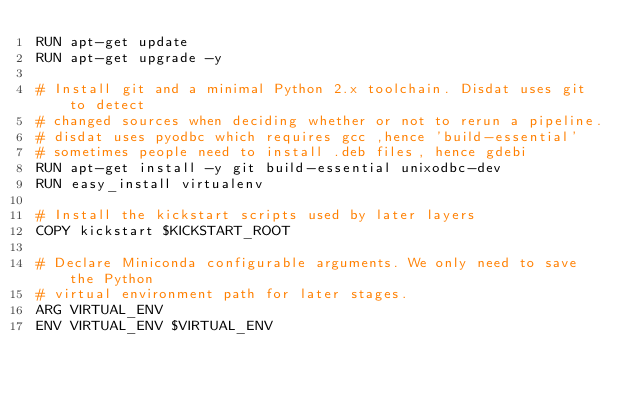<code> <loc_0><loc_0><loc_500><loc_500><_Dockerfile_>RUN apt-get update
RUN apt-get upgrade -y

# Install git and a minimal Python 2.x toolchain. Disdat uses git to detect
# changed sources when deciding whether or not to rerun a pipeline.
# disdat uses pyodbc which requires gcc ,hence 'build-essential'
# sometimes people need to install .deb files, hence gdebi
RUN apt-get install -y git build-essential unixodbc-dev
RUN easy_install virtualenv

# Install the kickstart scripts used by later layers
COPY kickstart $KICKSTART_ROOT

# Declare Miniconda configurable arguments. We only need to save the Python
# virtual environment path for later stages.
ARG VIRTUAL_ENV
ENV VIRTUAL_ENV $VIRTUAL_ENV

</code> 